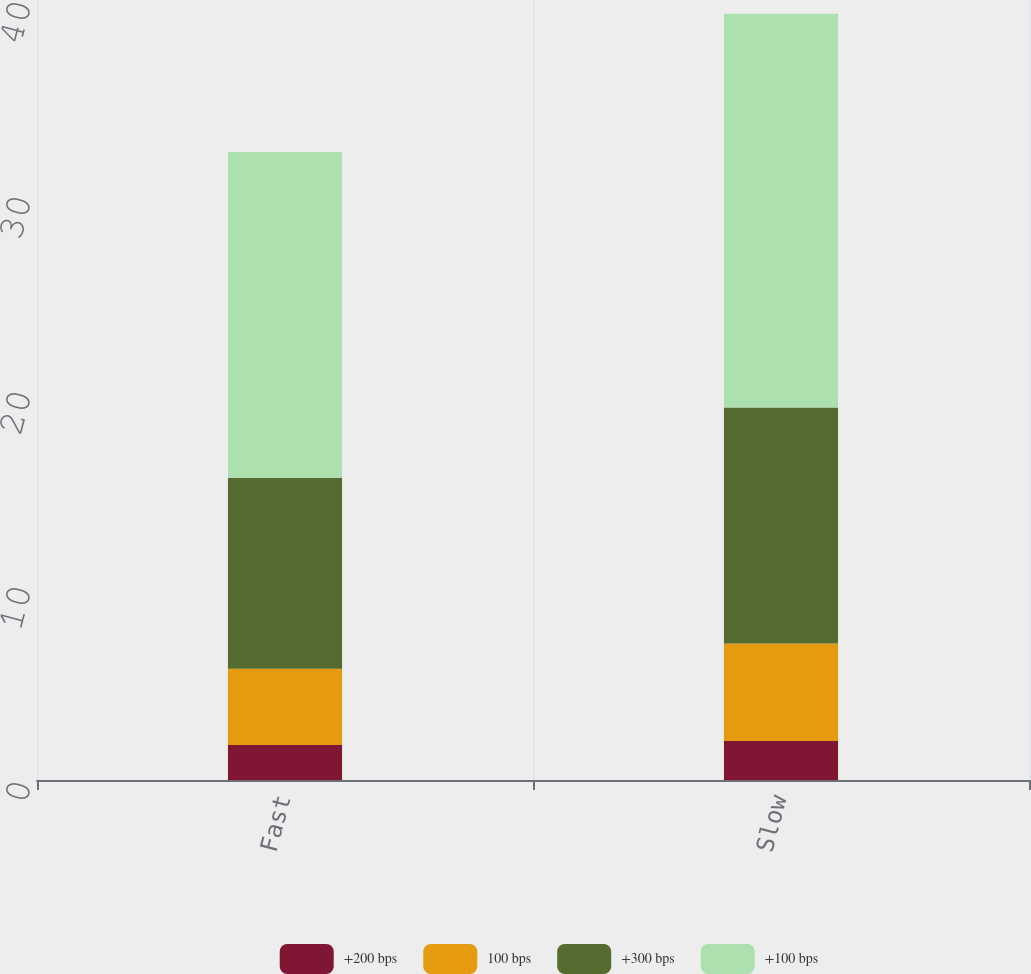<chart> <loc_0><loc_0><loc_500><loc_500><stacked_bar_chart><ecel><fcel>Fast<fcel>Slow<nl><fcel>+200 bps<fcel>1.8<fcel>2<nl><fcel>100 bps<fcel>3.9<fcel>5<nl><fcel>+300 bps<fcel>9.8<fcel>12.1<nl><fcel>+100 bps<fcel>16.7<fcel>20.2<nl></chart> 